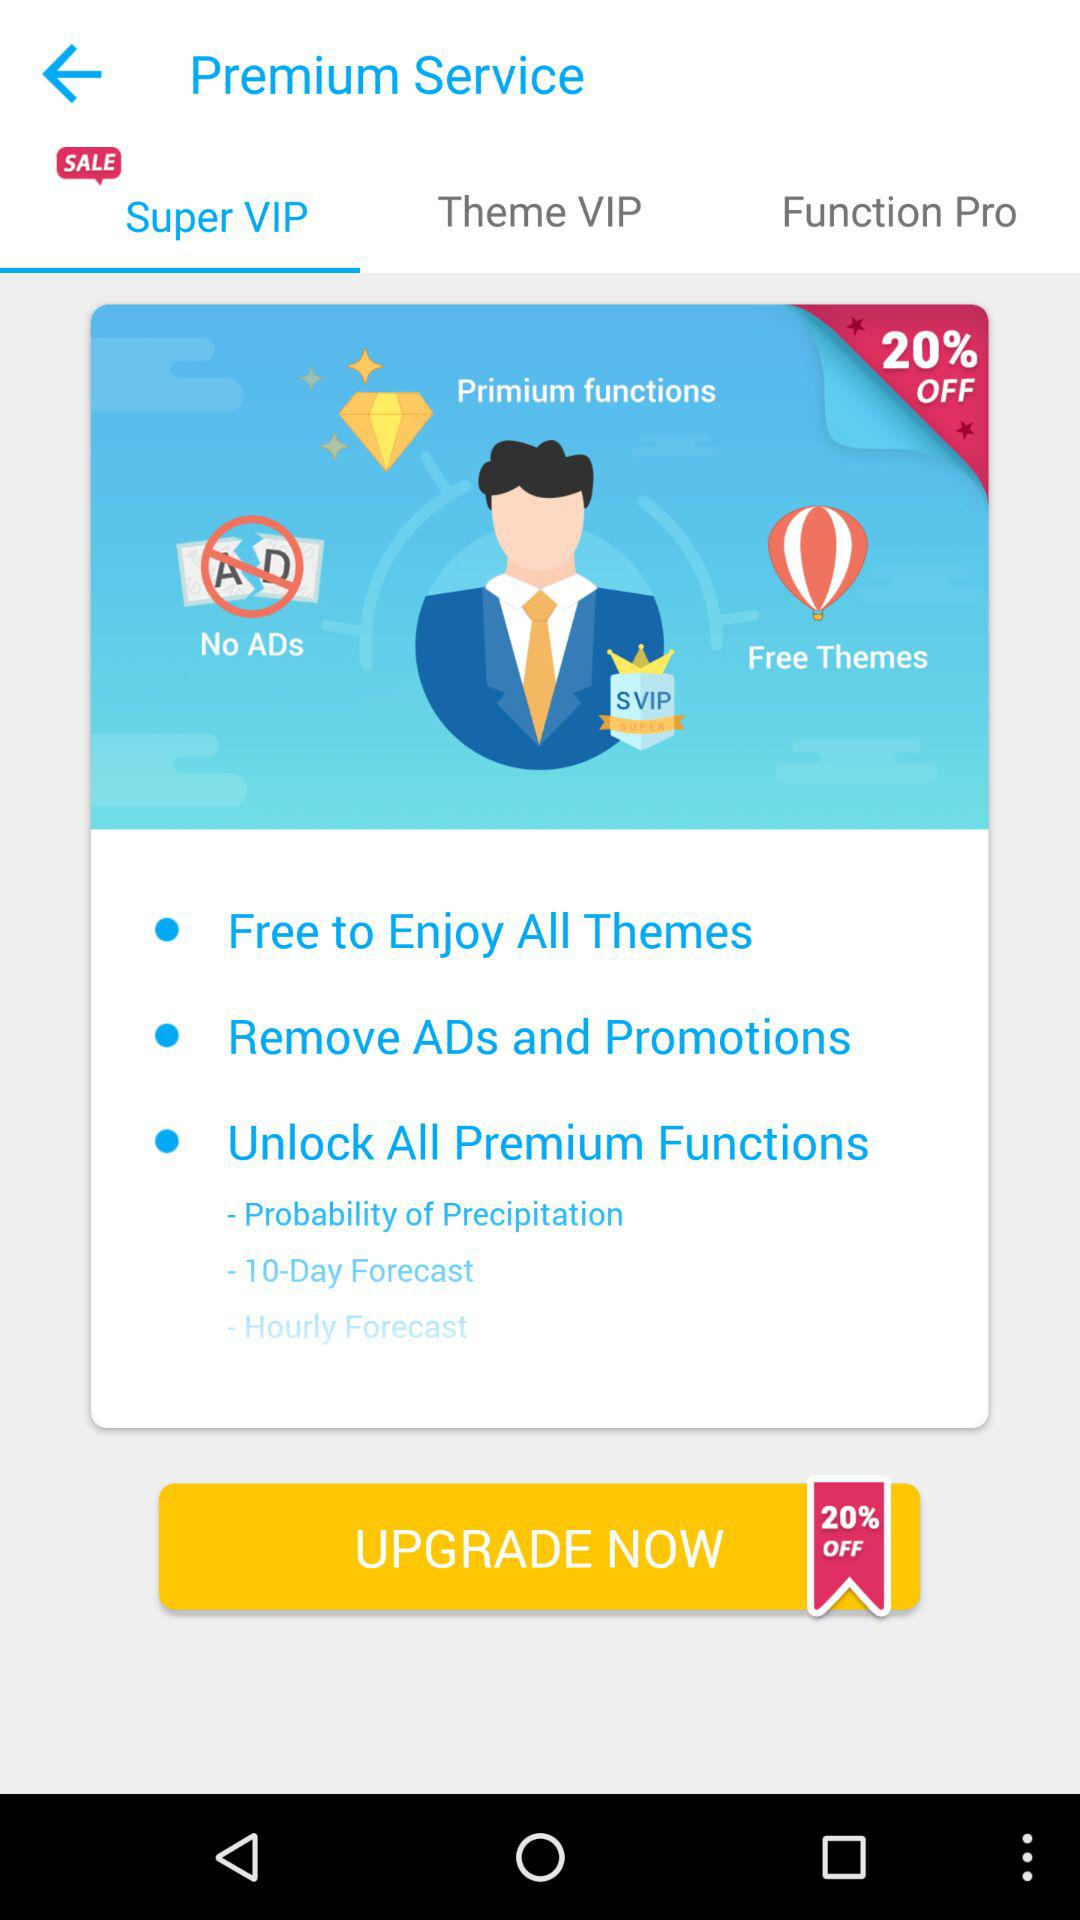What's percentage can I save on this application while upgrading premium version?
When the provided information is insufficient, respond with <no answer>. <no answer> 